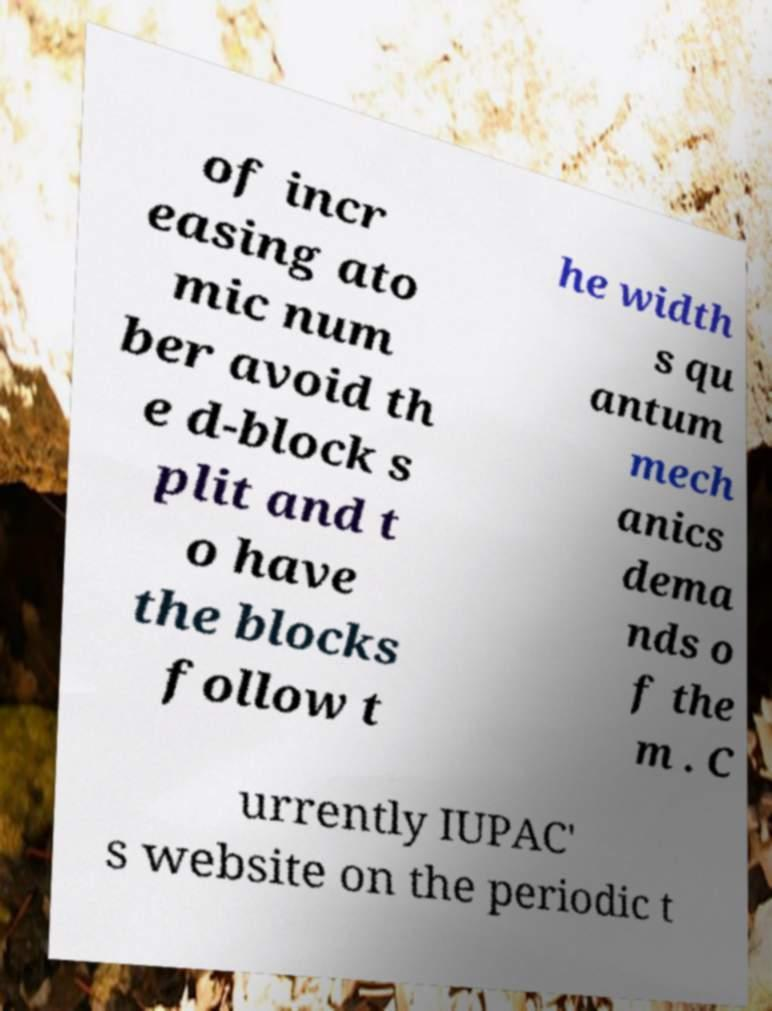Please identify and transcribe the text found in this image. of incr easing ato mic num ber avoid th e d-block s plit and t o have the blocks follow t he width s qu antum mech anics dema nds o f the m . C urrently IUPAC' s website on the periodic t 